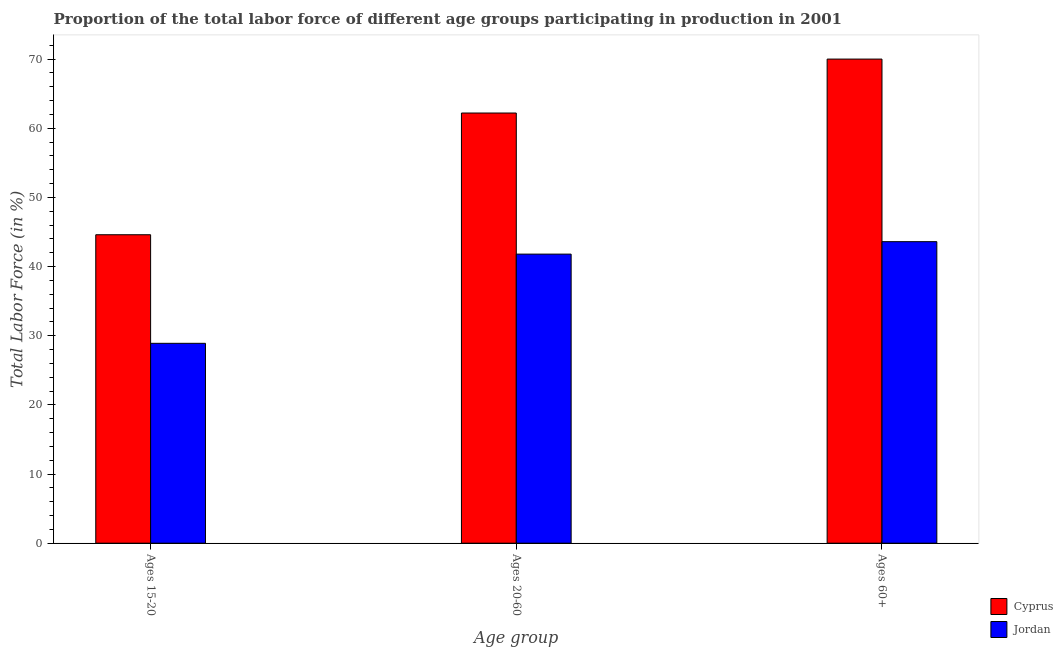How many groups of bars are there?
Keep it short and to the point. 3. Are the number of bars per tick equal to the number of legend labels?
Provide a short and direct response. Yes. How many bars are there on the 1st tick from the right?
Provide a succinct answer. 2. What is the label of the 3rd group of bars from the left?
Make the answer very short. Ages 60+. What is the percentage of labor force within the age group 15-20 in Jordan?
Offer a terse response. 28.9. Across all countries, what is the maximum percentage of labor force within the age group 20-60?
Your response must be concise. 62.2. Across all countries, what is the minimum percentage of labor force above age 60?
Provide a short and direct response. 43.6. In which country was the percentage of labor force above age 60 maximum?
Make the answer very short. Cyprus. In which country was the percentage of labor force above age 60 minimum?
Provide a short and direct response. Jordan. What is the total percentage of labor force within the age group 20-60 in the graph?
Offer a terse response. 104. What is the difference between the percentage of labor force above age 60 in Jordan and that in Cyprus?
Make the answer very short. -26.4. What is the average percentage of labor force above age 60 per country?
Your answer should be very brief. 56.8. What is the difference between the percentage of labor force within the age group 15-20 and percentage of labor force within the age group 20-60 in Jordan?
Offer a terse response. -12.9. In how many countries, is the percentage of labor force within the age group 15-20 greater than 22 %?
Provide a succinct answer. 2. What is the ratio of the percentage of labor force within the age group 20-60 in Cyprus to that in Jordan?
Your response must be concise. 1.49. Is the percentage of labor force above age 60 in Jordan less than that in Cyprus?
Your answer should be very brief. Yes. Is the difference between the percentage of labor force above age 60 in Cyprus and Jordan greater than the difference between the percentage of labor force within the age group 15-20 in Cyprus and Jordan?
Your response must be concise. Yes. What is the difference between the highest and the second highest percentage of labor force above age 60?
Keep it short and to the point. 26.4. What is the difference between the highest and the lowest percentage of labor force above age 60?
Ensure brevity in your answer.  26.4. What does the 1st bar from the left in Ages 60+ represents?
Your response must be concise. Cyprus. What does the 2nd bar from the right in Ages 15-20 represents?
Your answer should be compact. Cyprus. Are all the bars in the graph horizontal?
Keep it short and to the point. No. Does the graph contain grids?
Your response must be concise. No. Where does the legend appear in the graph?
Offer a terse response. Bottom right. What is the title of the graph?
Give a very brief answer. Proportion of the total labor force of different age groups participating in production in 2001. What is the label or title of the X-axis?
Your answer should be compact. Age group. What is the Total Labor Force (in %) of Cyprus in Ages 15-20?
Your answer should be compact. 44.6. What is the Total Labor Force (in %) in Jordan in Ages 15-20?
Offer a very short reply. 28.9. What is the Total Labor Force (in %) in Cyprus in Ages 20-60?
Keep it short and to the point. 62.2. What is the Total Labor Force (in %) of Jordan in Ages 20-60?
Offer a very short reply. 41.8. What is the Total Labor Force (in %) of Cyprus in Ages 60+?
Make the answer very short. 70. What is the Total Labor Force (in %) in Jordan in Ages 60+?
Give a very brief answer. 43.6. Across all Age group, what is the maximum Total Labor Force (in %) in Jordan?
Ensure brevity in your answer.  43.6. Across all Age group, what is the minimum Total Labor Force (in %) of Cyprus?
Offer a very short reply. 44.6. Across all Age group, what is the minimum Total Labor Force (in %) in Jordan?
Your response must be concise. 28.9. What is the total Total Labor Force (in %) in Cyprus in the graph?
Your answer should be compact. 176.8. What is the total Total Labor Force (in %) of Jordan in the graph?
Give a very brief answer. 114.3. What is the difference between the Total Labor Force (in %) of Cyprus in Ages 15-20 and that in Ages 20-60?
Ensure brevity in your answer.  -17.6. What is the difference between the Total Labor Force (in %) in Cyprus in Ages 15-20 and that in Ages 60+?
Offer a very short reply. -25.4. What is the difference between the Total Labor Force (in %) in Jordan in Ages 15-20 and that in Ages 60+?
Provide a succinct answer. -14.7. What is the difference between the Total Labor Force (in %) in Jordan in Ages 20-60 and that in Ages 60+?
Offer a terse response. -1.8. What is the difference between the Total Labor Force (in %) of Cyprus in Ages 15-20 and the Total Labor Force (in %) of Jordan in Ages 20-60?
Provide a succinct answer. 2.8. What is the average Total Labor Force (in %) of Cyprus per Age group?
Your response must be concise. 58.93. What is the average Total Labor Force (in %) in Jordan per Age group?
Your answer should be very brief. 38.1. What is the difference between the Total Labor Force (in %) of Cyprus and Total Labor Force (in %) of Jordan in Ages 15-20?
Provide a short and direct response. 15.7. What is the difference between the Total Labor Force (in %) of Cyprus and Total Labor Force (in %) of Jordan in Ages 20-60?
Keep it short and to the point. 20.4. What is the difference between the Total Labor Force (in %) of Cyprus and Total Labor Force (in %) of Jordan in Ages 60+?
Keep it short and to the point. 26.4. What is the ratio of the Total Labor Force (in %) in Cyprus in Ages 15-20 to that in Ages 20-60?
Keep it short and to the point. 0.72. What is the ratio of the Total Labor Force (in %) in Jordan in Ages 15-20 to that in Ages 20-60?
Make the answer very short. 0.69. What is the ratio of the Total Labor Force (in %) in Cyprus in Ages 15-20 to that in Ages 60+?
Offer a very short reply. 0.64. What is the ratio of the Total Labor Force (in %) of Jordan in Ages 15-20 to that in Ages 60+?
Provide a succinct answer. 0.66. What is the ratio of the Total Labor Force (in %) of Cyprus in Ages 20-60 to that in Ages 60+?
Provide a short and direct response. 0.89. What is the ratio of the Total Labor Force (in %) of Jordan in Ages 20-60 to that in Ages 60+?
Give a very brief answer. 0.96. What is the difference between the highest and the lowest Total Labor Force (in %) in Cyprus?
Provide a short and direct response. 25.4. 